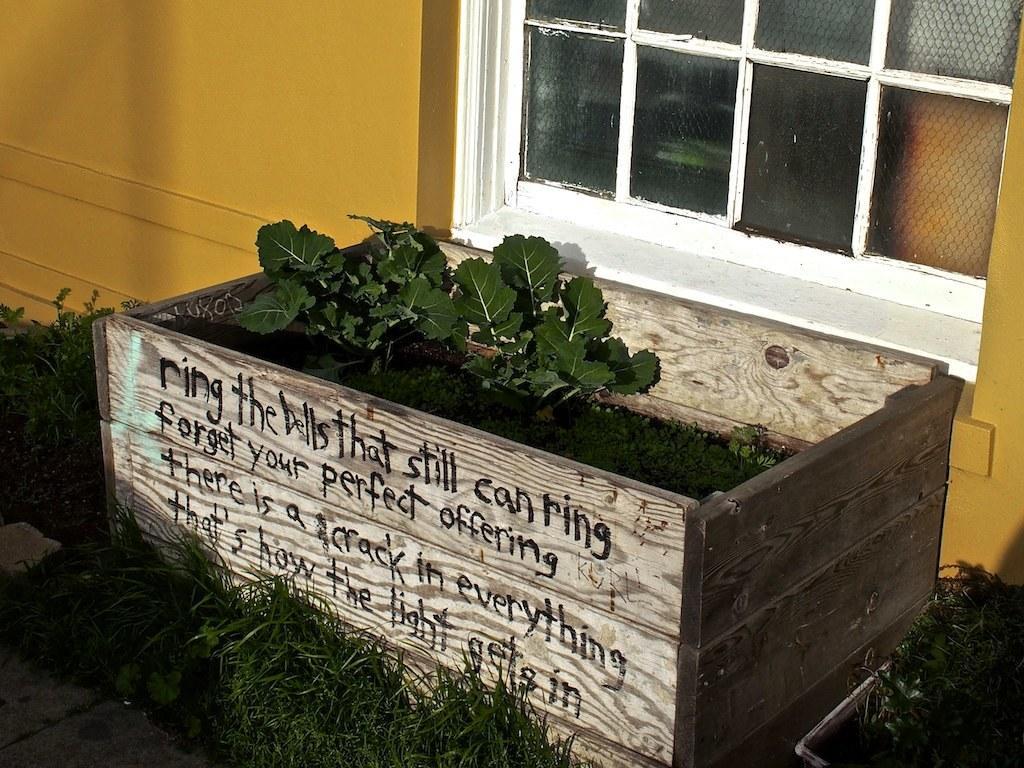Can you describe this image briefly? This picture shows plants in the wooden box and we see text on the box and a wall with glass window and we see grass on the ground. 